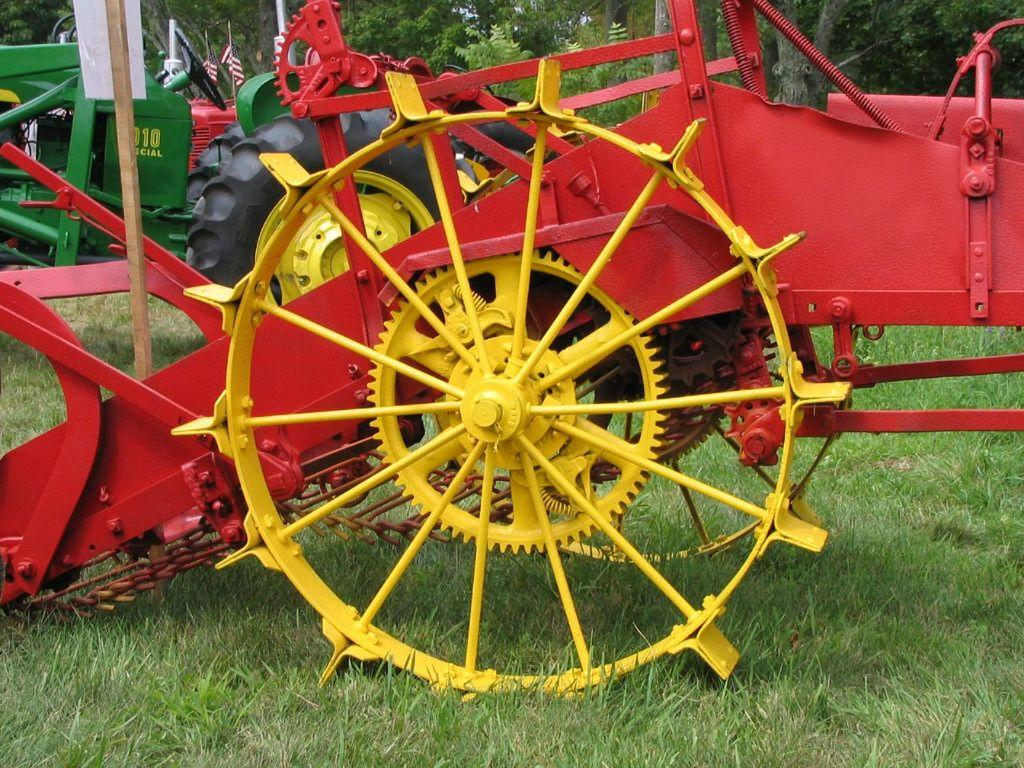What is the main subject of the image? There is a vehicle in the image. What can be seen in the background of the image? There are trees in the background of the image. What type of terrain is visible in the image? There is grass on the ground in the image. What is the purpose of the rail in the image? There is no rail present in the image; it only features a vehicle, trees in the background, and grass on the ground. 